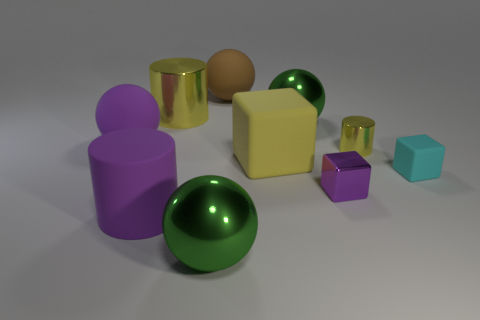Subtract all cubes. How many objects are left? 7 Subtract all tiny rubber cubes. Subtract all large red spheres. How many objects are left? 9 Add 6 big cubes. How many big cubes are left? 7 Add 5 green shiny cylinders. How many green shiny cylinders exist? 5 Subtract 0 gray cubes. How many objects are left? 10 